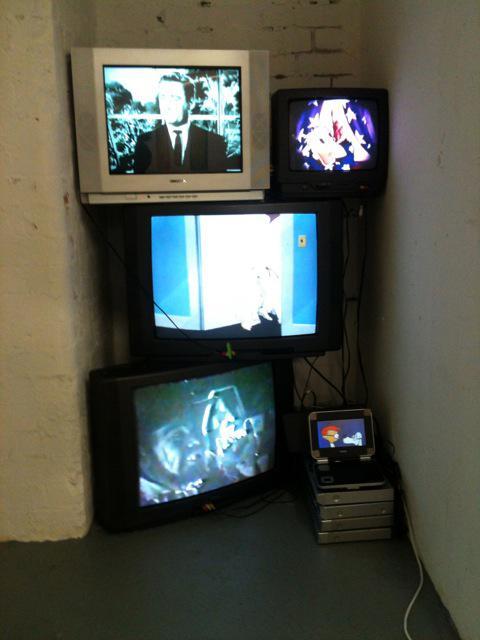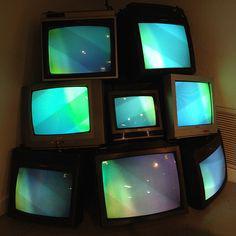The first image is the image on the left, the second image is the image on the right. Given the left and right images, does the statement "There are nine identical TVs placed on each other with exactly two circle knobs on the right hand side of each of the nine televisions." hold true? Answer yes or no. No. The first image is the image on the left, the second image is the image on the right. Evaluate the accuracy of this statement regarding the images: "There are three stacks of  televisions stacked three high next to each other.". Is it true? Answer yes or no. No. 